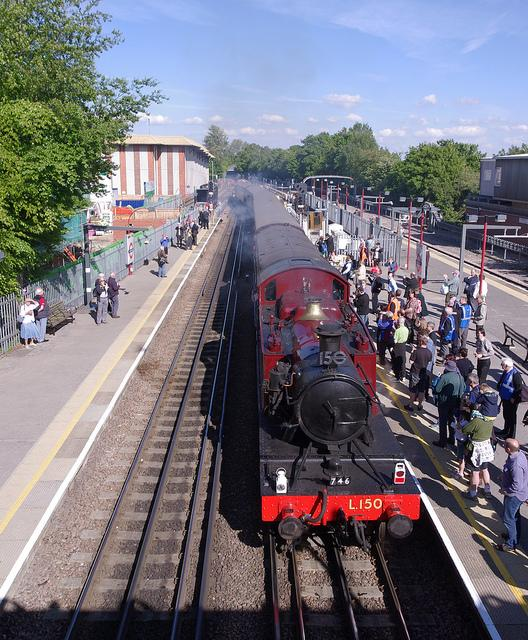What is the gold object near the front of the train?

Choices:
A) shield
B) handle
C) bell
D) helmet bell 